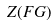<formula> <loc_0><loc_0><loc_500><loc_500>Z ( F G )</formula> 